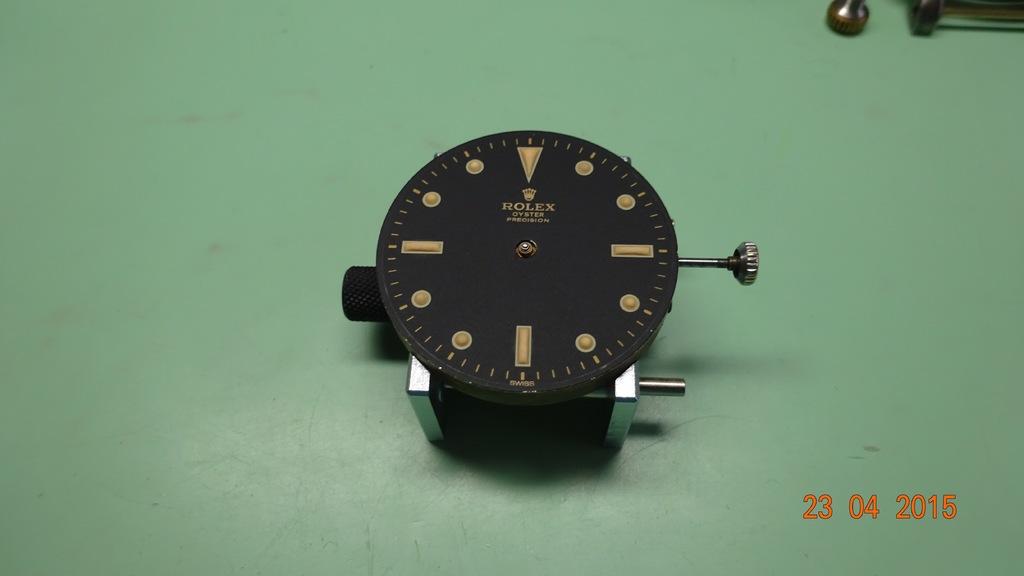What is the brand of this watch?
Keep it short and to the point. Rolex. Who is the watch maker?
Your answer should be compact. Rolex. 